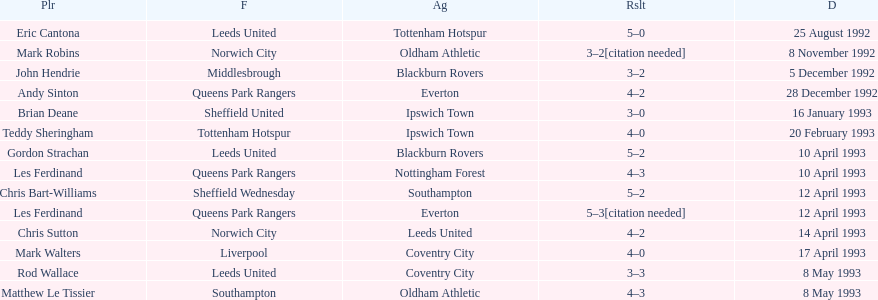Who does john hendrie play for? Middlesbrough. 